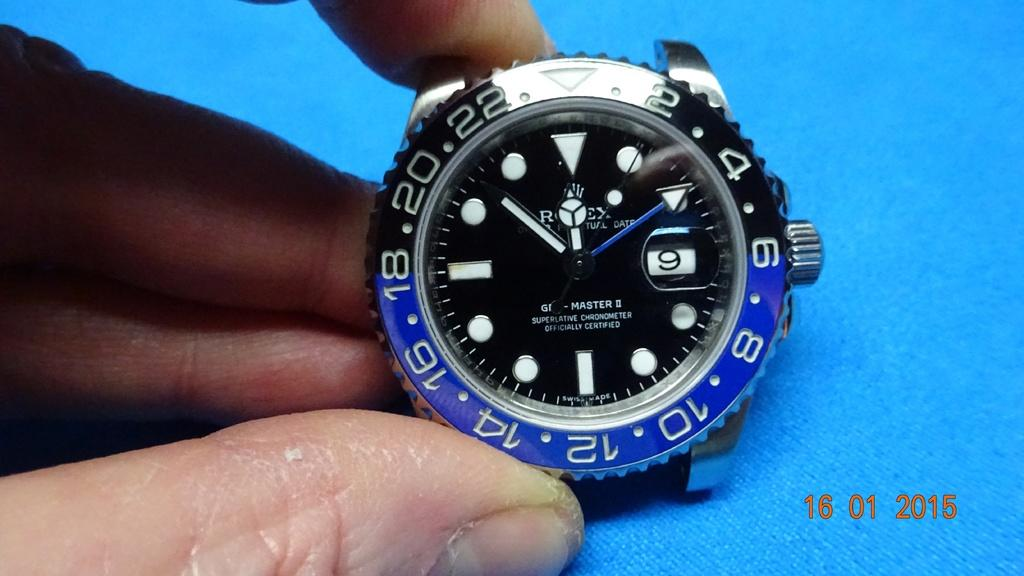What is the main subject of the image? The main subject of the image is a human hand. What is the hand holding? The hand is holding a watch. What type of scarecrow is visible in the image? There is no scarecrow present in the image; it features a human hand holding a watch. What type of pipe is being smoked by the person in the image? There is no person or pipe visible in the image; it only shows a human hand holding a watch. 